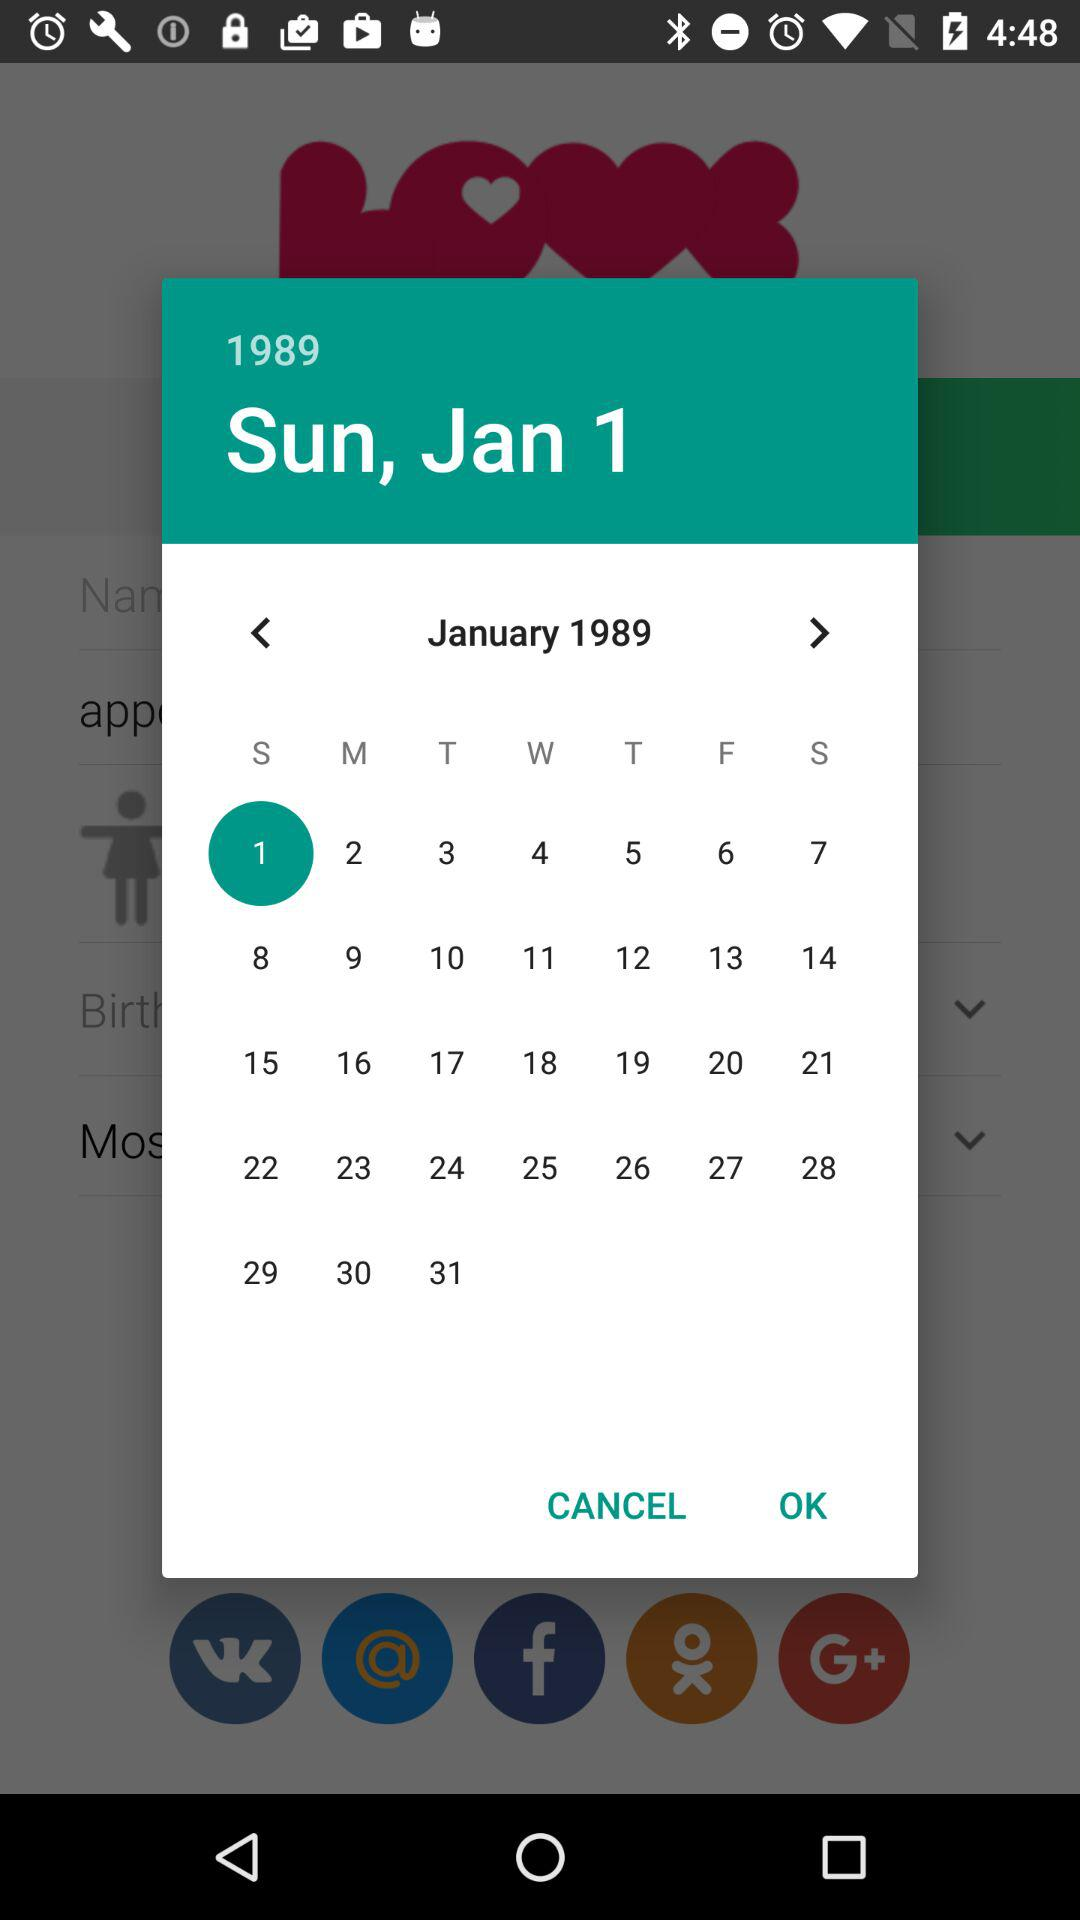What is the selected date? The selected date is Sunday, January 1, 1989. 